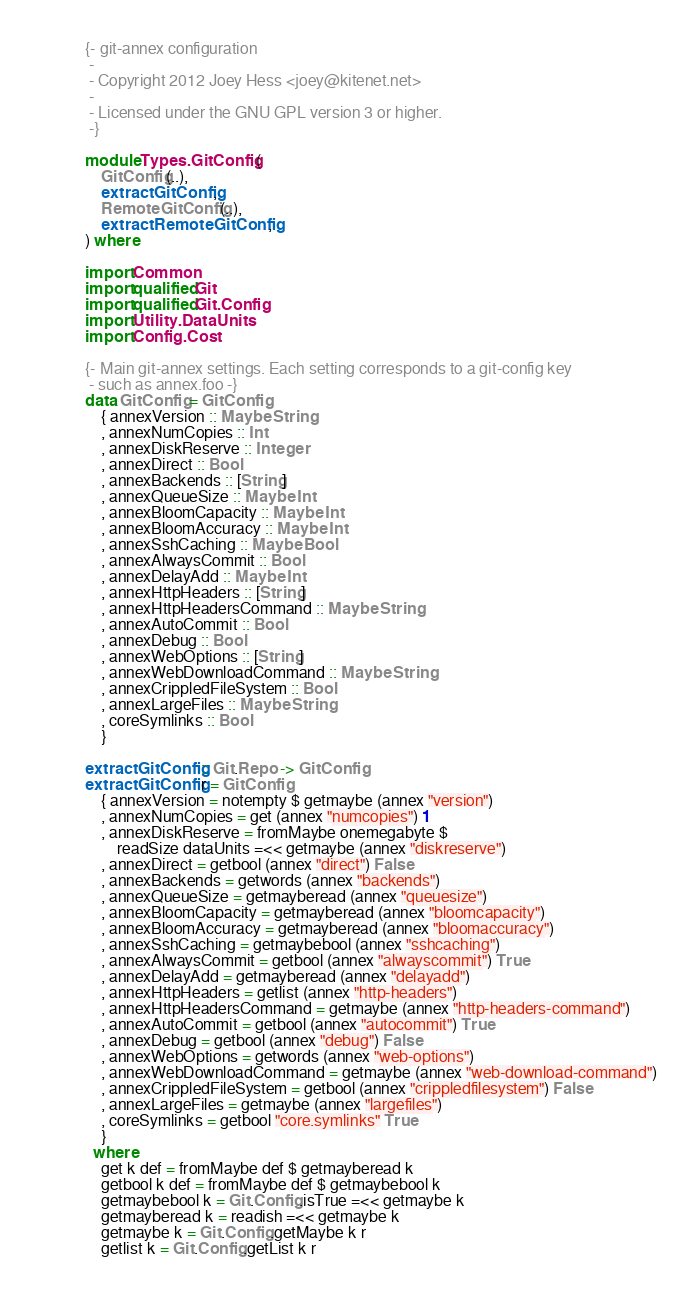<code> <loc_0><loc_0><loc_500><loc_500><_Haskell_>{- git-annex configuration
 -
 - Copyright 2012 Joey Hess <joey@kitenet.net>
 -
 - Licensed under the GNU GPL version 3 or higher.
 -}

module Types.GitConfig ( 
	GitConfig(..),
	extractGitConfig,
	RemoteGitConfig(..),
	extractRemoteGitConfig,
) where

import Common
import qualified Git
import qualified Git.Config
import Utility.DataUnits
import Config.Cost

{- Main git-annex settings. Each setting corresponds to a git-config key
 - such as annex.foo -}
data GitConfig = GitConfig
	{ annexVersion :: Maybe String
	, annexNumCopies :: Int
	, annexDiskReserve :: Integer
	, annexDirect :: Bool
	, annexBackends :: [String]
	, annexQueueSize :: Maybe Int
	, annexBloomCapacity :: Maybe Int
	, annexBloomAccuracy :: Maybe Int
	, annexSshCaching :: Maybe Bool
	, annexAlwaysCommit :: Bool
	, annexDelayAdd :: Maybe Int
	, annexHttpHeaders :: [String]
	, annexHttpHeadersCommand :: Maybe String
	, annexAutoCommit :: Bool
	, annexDebug :: Bool
	, annexWebOptions :: [String]
	, annexWebDownloadCommand :: Maybe String
	, annexCrippledFileSystem :: Bool
	, annexLargeFiles :: Maybe String
	, coreSymlinks :: Bool
	}

extractGitConfig :: Git.Repo -> GitConfig
extractGitConfig r = GitConfig
	{ annexVersion = notempty $ getmaybe (annex "version")
	, annexNumCopies = get (annex "numcopies") 1
	, annexDiskReserve = fromMaybe onemegabyte $
		readSize dataUnits =<< getmaybe (annex "diskreserve")
	, annexDirect = getbool (annex "direct") False
	, annexBackends = getwords (annex "backends")
	, annexQueueSize = getmayberead (annex "queuesize")
	, annexBloomCapacity = getmayberead (annex "bloomcapacity")
	, annexBloomAccuracy = getmayberead (annex "bloomaccuracy")
	, annexSshCaching = getmaybebool (annex "sshcaching")
	, annexAlwaysCommit = getbool (annex "alwayscommit") True
	, annexDelayAdd = getmayberead (annex "delayadd")
	, annexHttpHeaders = getlist (annex "http-headers")
	, annexHttpHeadersCommand = getmaybe (annex "http-headers-command")
	, annexAutoCommit = getbool (annex "autocommit") True
	, annexDebug = getbool (annex "debug") False
	, annexWebOptions = getwords (annex "web-options")
	, annexWebDownloadCommand = getmaybe (annex "web-download-command")
	, annexCrippledFileSystem = getbool (annex "crippledfilesystem") False
	, annexLargeFiles = getmaybe (annex "largefiles")
	, coreSymlinks = getbool "core.symlinks" True
	}
  where
	get k def = fromMaybe def $ getmayberead k
	getbool k def = fromMaybe def $ getmaybebool k
	getmaybebool k = Git.Config.isTrue =<< getmaybe k
	getmayberead k = readish =<< getmaybe k
	getmaybe k = Git.Config.getMaybe k r
	getlist k = Git.Config.getList k r</code> 